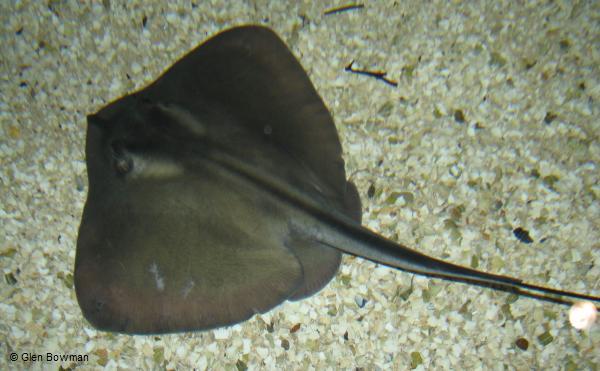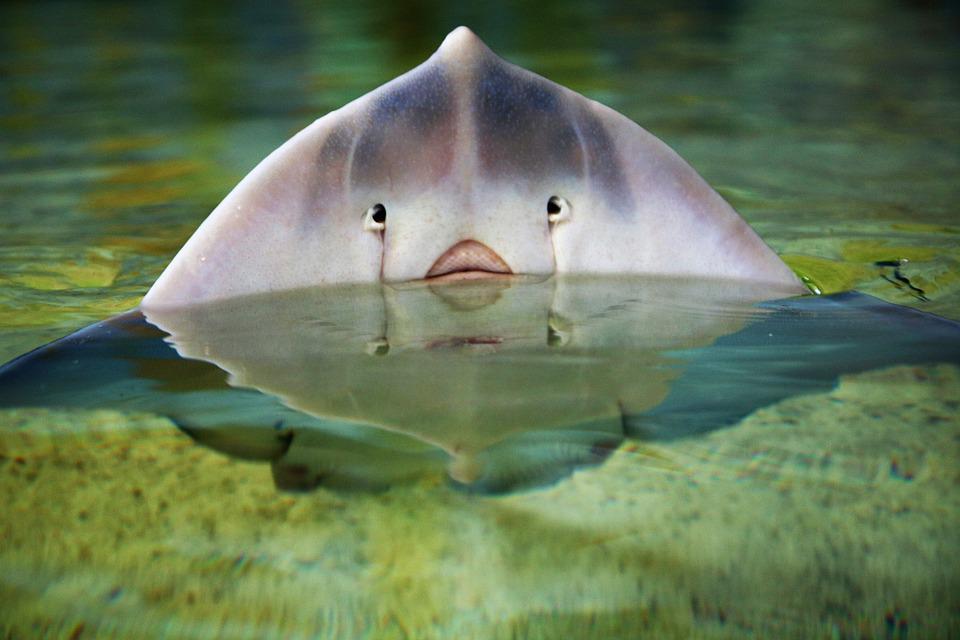The first image is the image on the left, the second image is the image on the right. Assess this claim about the two images: "There is a stingray with its tail going towards a bottom corner.". Correct or not? Answer yes or no. Yes. 